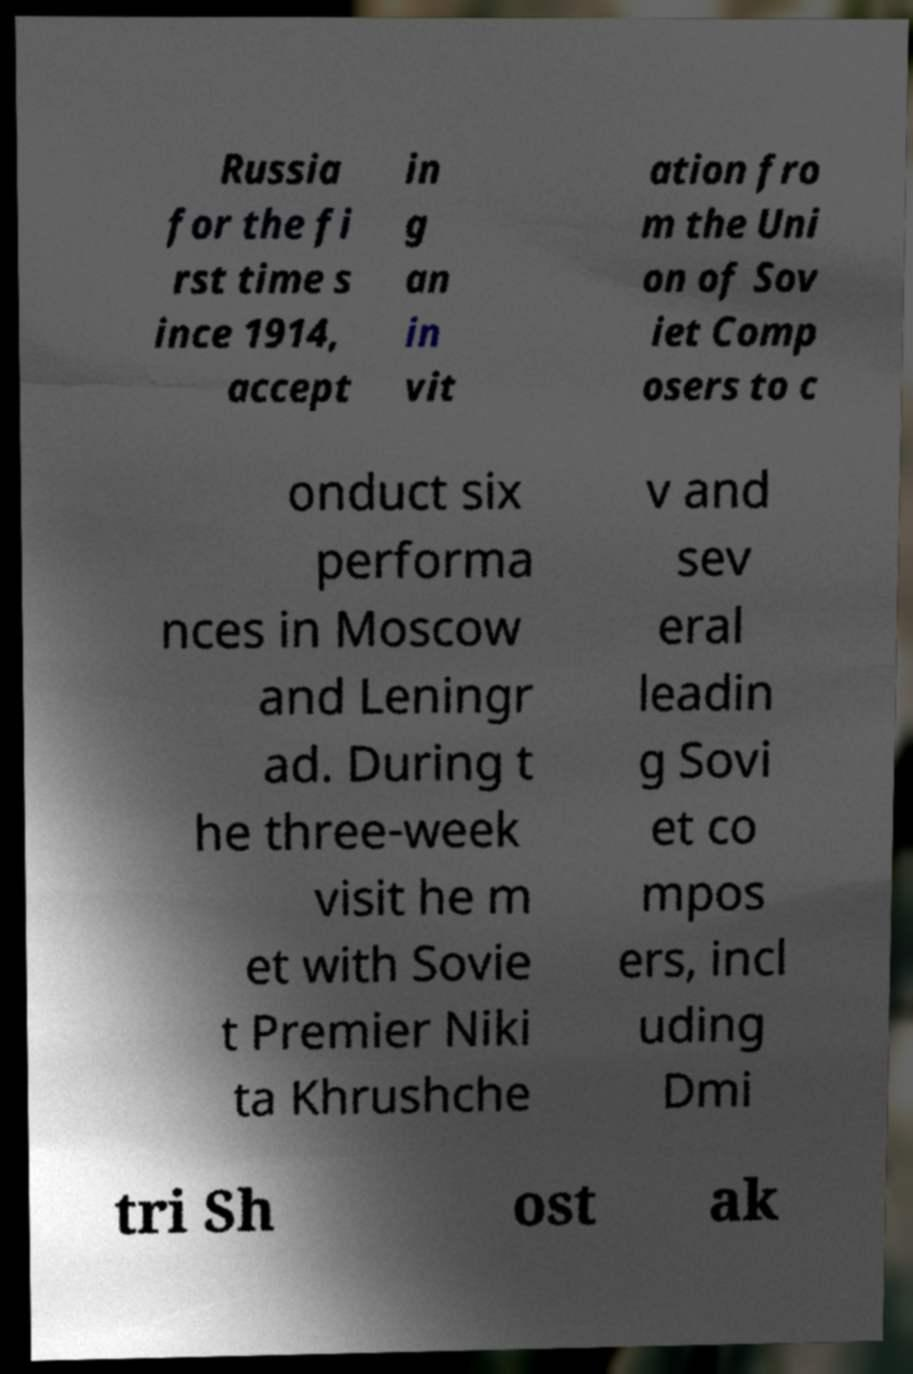Please identify and transcribe the text found in this image. Russia for the fi rst time s ince 1914, accept in g an in vit ation fro m the Uni on of Sov iet Comp osers to c onduct six performa nces in Moscow and Leningr ad. During t he three-week visit he m et with Sovie t Premier Niki ta Khrushche v and sev eral leadin g Sovi et co mpos ers, incl uding Dmi tri Sh ost ak 